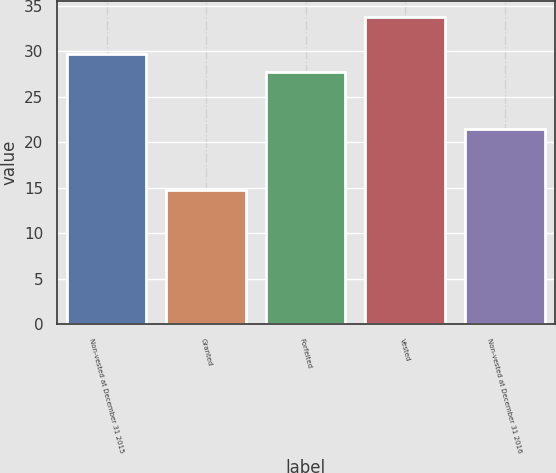<chart> <loc_0><loc_0><loc_500><loc_500><bar_chart><fcel>Non-vested at December 31 2015<fcel>Granted<fcel>Forfeited<fcel>Vested<fcel>Non-vested at December 31 2016<nl><fcel>29.67<fcel>14.73<fcel>27.76<fcel>33.81<fcel>21.47<nl></chart> 